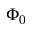Convert formula to latex. <formula><loc_0><loc_0><loc_500><loc_500>\Phi _ { 0 }</formula> 